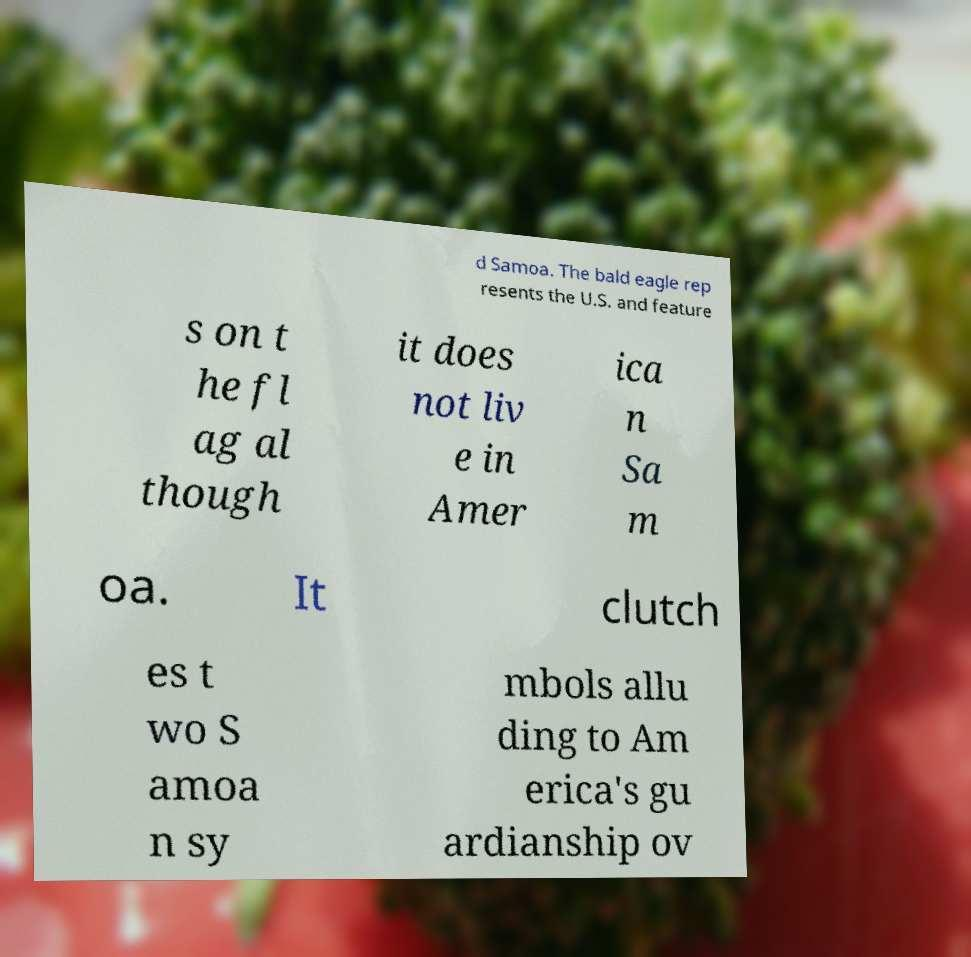Can you read and provide the text displayed in the image?This photo seems to have some interesting text. Can you extract and type it out for me? d Samoa. The bald eagle rep resents the U.S. and feature s on t he fl ag al though it does not liv e in Amer ica n Sa m oa. It clutch es t wo S amoa n sy mbols allu ding to Am erica's gu ardianship ov 